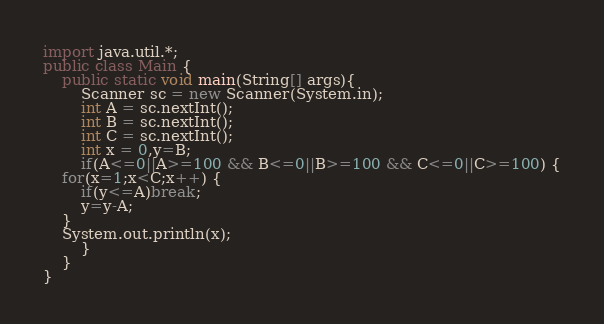Convert code to text. <code><loc_0><loc_0><loc_500><loc_500><_Java_>import java.util.*;
public class Main {
	public static void main(String[] args){
		Scanner sc = new Scanner(System.in);
		int A = sc.nextInt();
		int B = sc.nextInt();
		int C = sc.nextInt();
		int x = 0,y=B;
		if(A<=0||A>=100 && B<=0||B>=100 && C<=0||C>=100) {
	for(x=1;x<C;x++) {
		if(y<=A)break;
		y=y-A;
	}
	System.out.println(x);
		}
	}
}</code> 